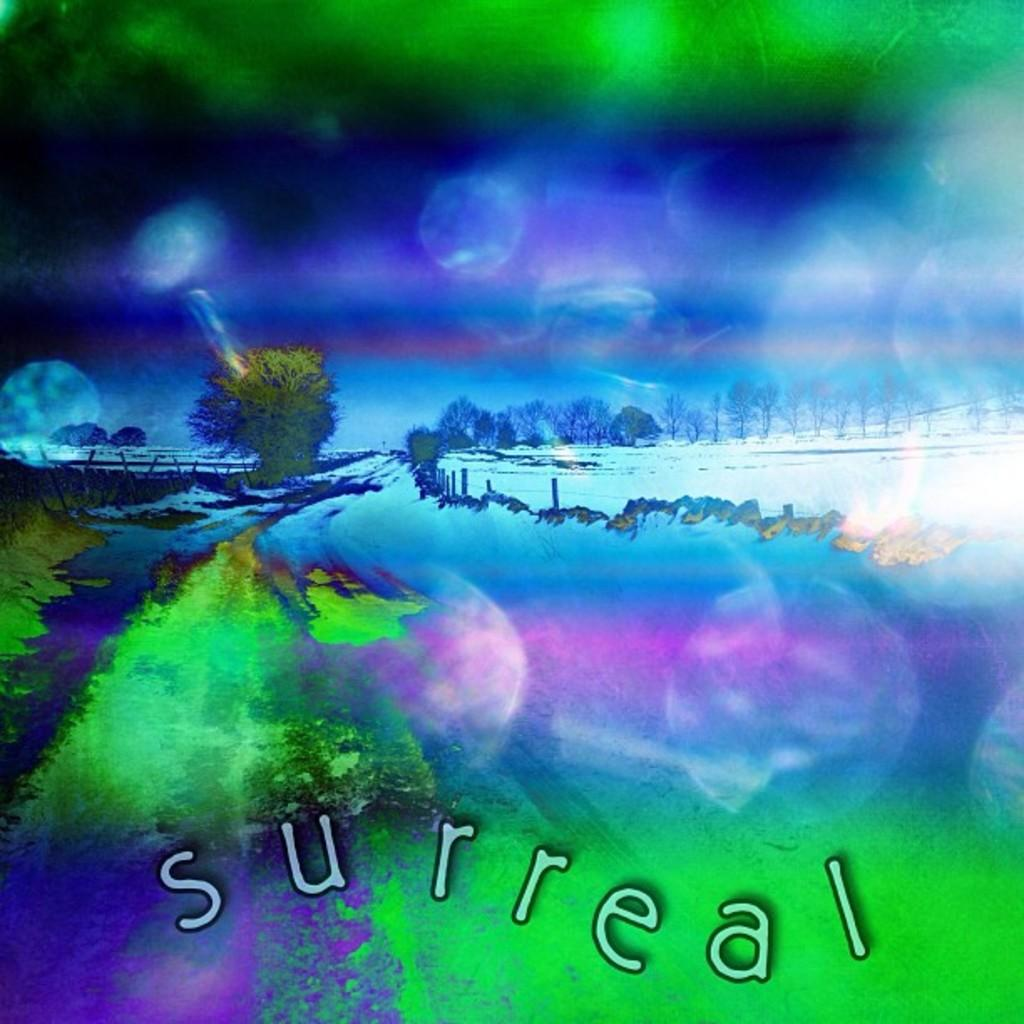What type of image is being described? The image is an edited picture. What can be seen in the natural environment of the image? There are many trees and snow in the image. What man-made structures are present in the image? There are poles in the image. What is visible in the sky in the image? The sky is visible in the image. What is written or displayed at the bottom of the image? There is text at the bottom of the image. How many gloves can be seen in the image? There are no gloves present in the image. What time does the clock in the image show? There are no clocks present in the image. 